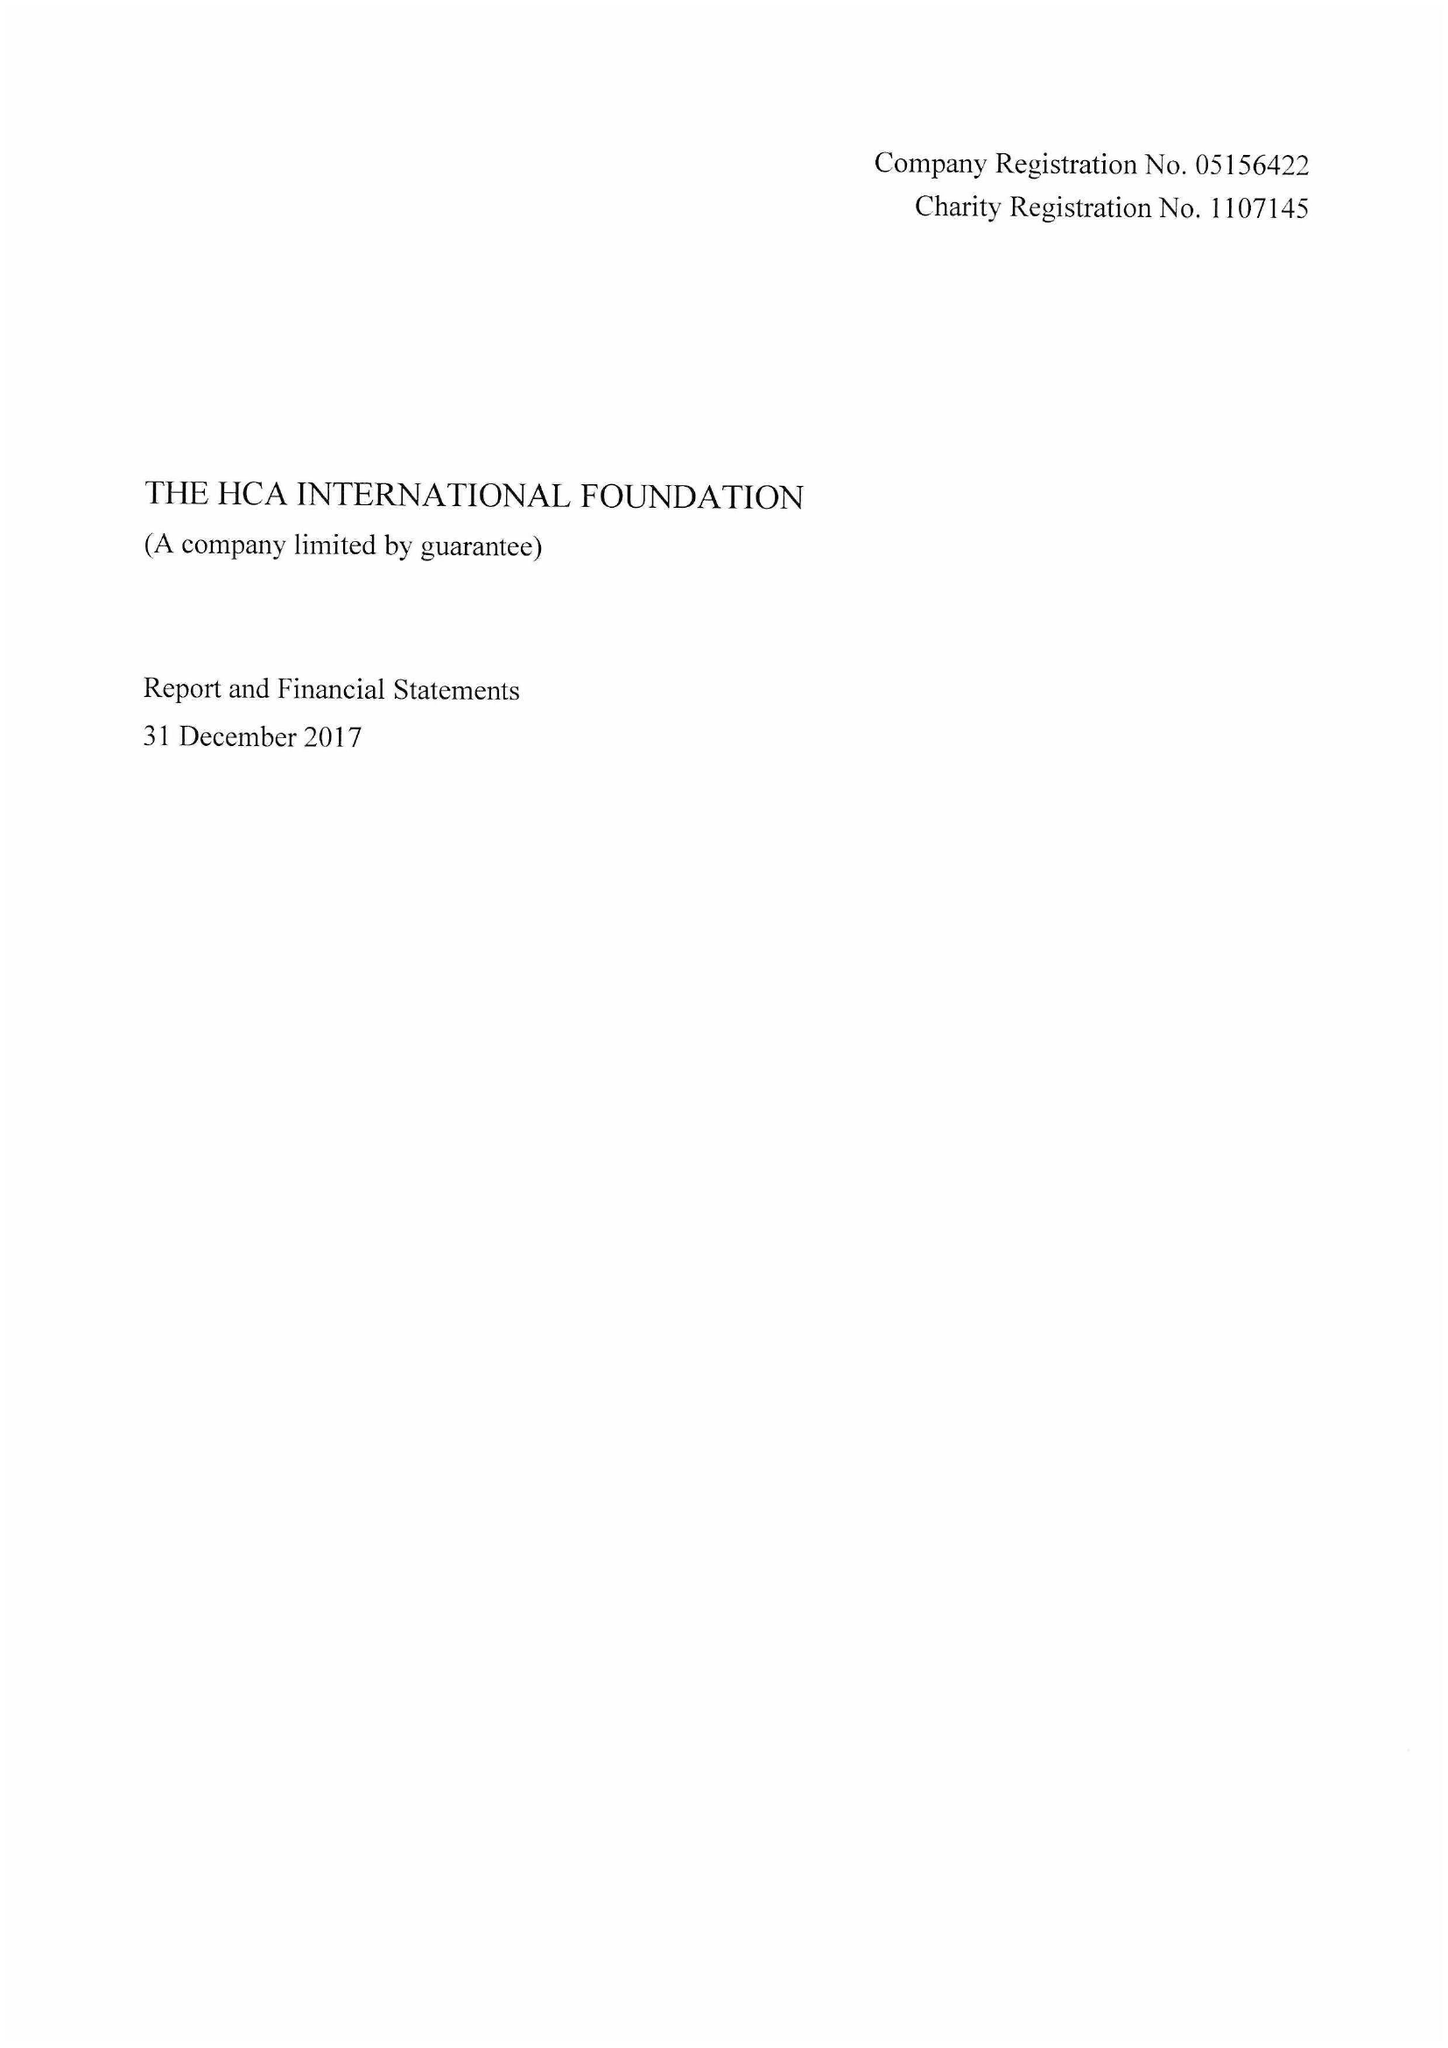What is the value for the income_annually_in_british_pounds?
Answer the question using a single word or phrase. 100000.00 